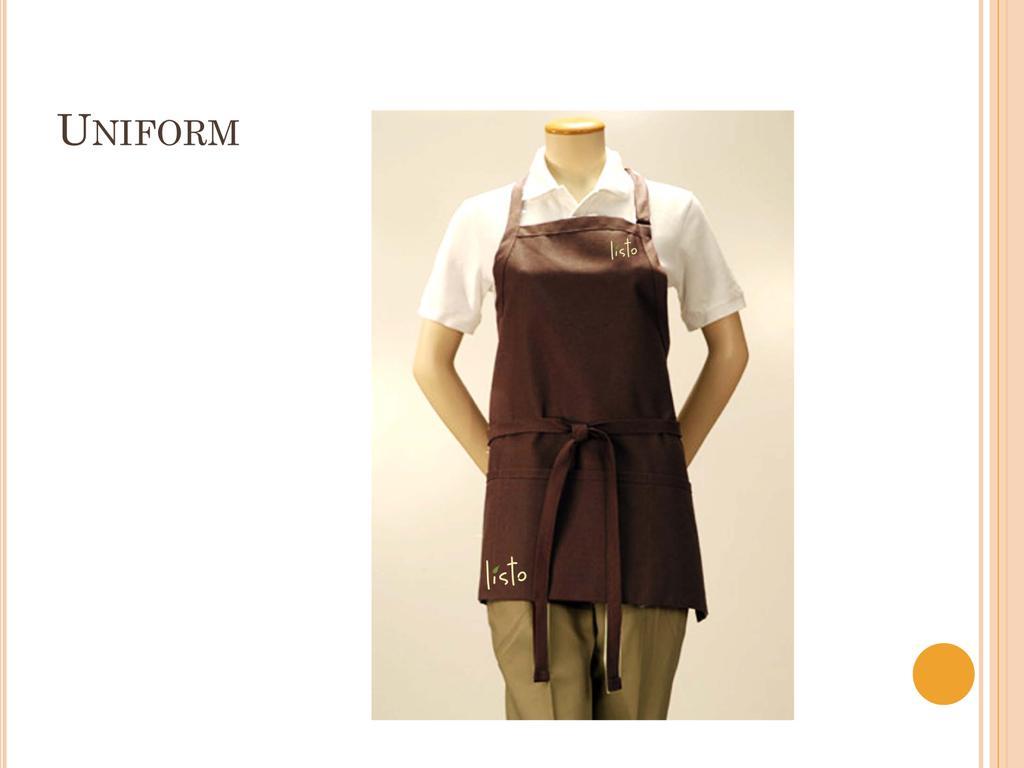In one or two sentences, can you explain what this image depicts? In this image we can see there is a depiction of a person without head wearing a uniform, beside that at the top left side of the image there is a text. 